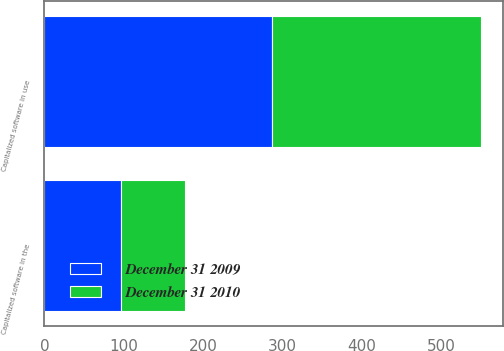<chart> <loc_0><loc_0><loc_500><loc_500><stacked_bar_chart><ecel><fcel>Capitalized software in use<fcel>Capitalized software in the<nl><fcel>December 31 2009<fcel>287<fcel>96<nl><fcel>December 31 2010<fcel>263<fcel>81<nl></chart> 